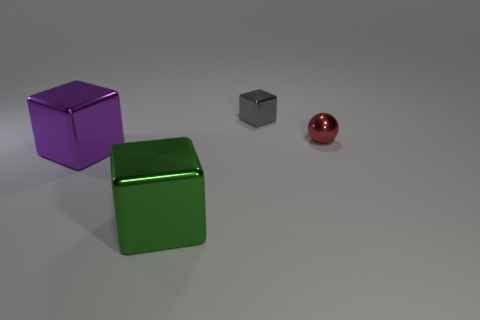There is a big metal block that is to the left of the big green block; what number of large purple objects are right of it?
Your answer should be very brief. 0. What shape is the tiny red thing that is made of the same material as the big purple block?
Ensure brevity in your answer.  Sphere. Is the color of the tiny block the same as the metallic sphere?
Keep it short and to the point. No. Do the thing that is in front of the purple cube and the thing right of the small metal block have the same material?
Your response must be concise. Yes. How many objects are either blue metal cubes or metal spheres in front of the tiny shiny cube?
Offer a very short reply. 1. What number of metal things are either green cubes or tiny spheres?
Keep it short and to the point. 2. What is the shape of the thing to the right of the gray cube?
Offer a very short reply. Sphere. What is the size of the purple block that is the same material as the small gray thing?
Offer a very short reply. Large. What shape is the object that is both behind the green block and to the left of the small gray block?
Your response must be concise. Cube. Do the green thing to the left of the gray thing and the small object that is behind the tiny red ball have the same shape?
Ensure brevity in your answer.  Yes. 